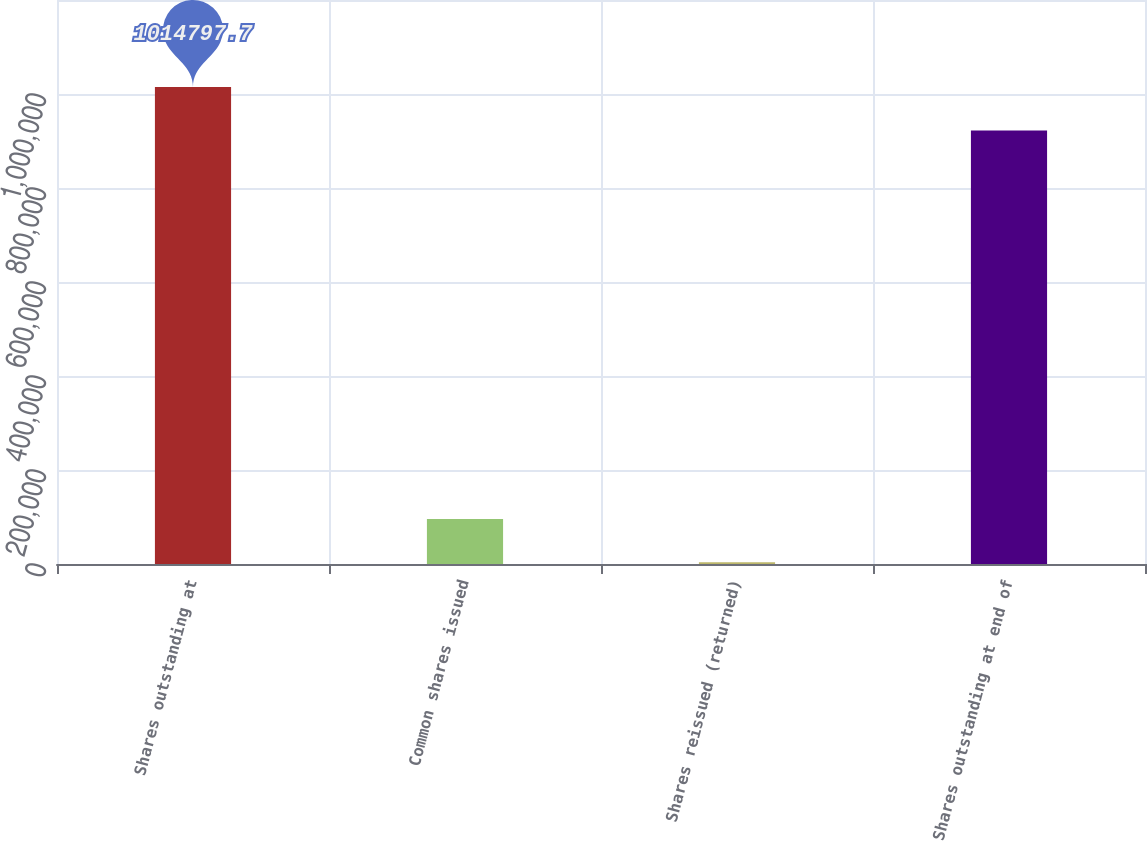Convert chart to OTSL. <chart><loc_0><loc_0><loc_500><loc_500><bar_chart><fcel>Shares outstanding at<fcel>Common shares issued<fcel>Shares reissued (returned)<fcel>Shares outstanding at end of<nl><fcel>1.0148e+06<fcel>95818.7<fcel>3602<fcel>922581<nl></chart> 